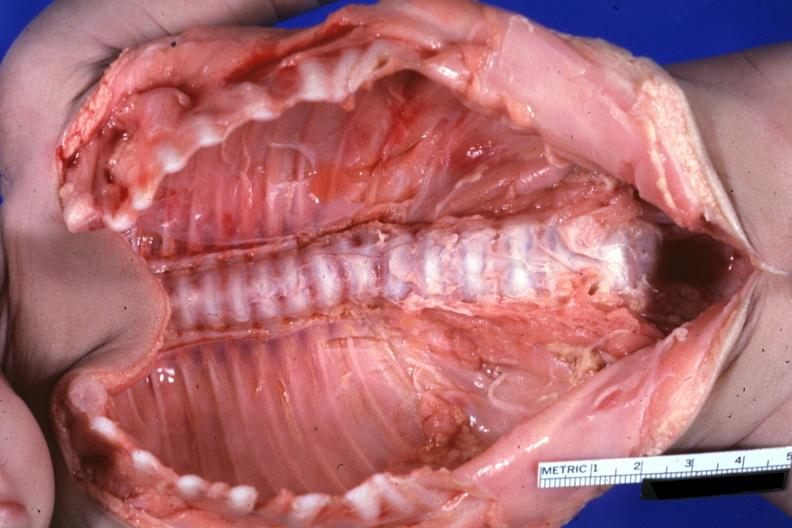what does this image show?
Answer the question using a single word or phrase. Opened body cavity natural color lesion at t12 see protocol 